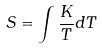Convert formula to latex. <formula><loc_0><loc_0><loc_500><loc_500>S = \int \frac { K } { T } d T</formula> 